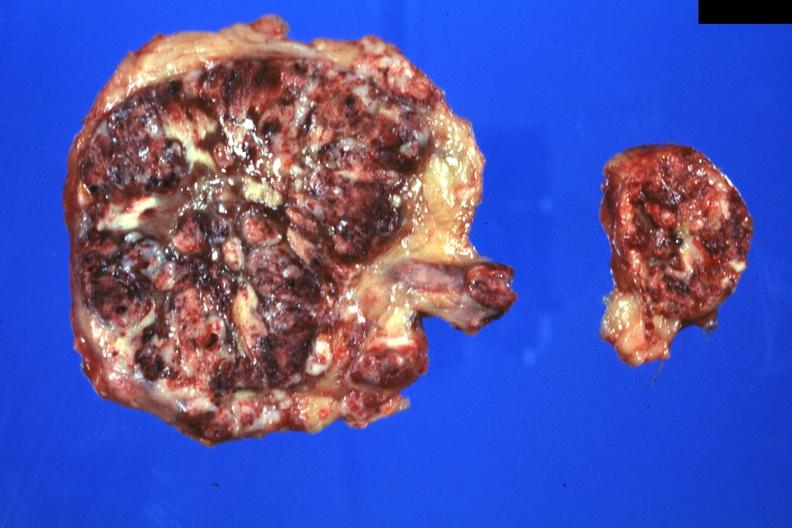what does this image show?
Answer the question using a single word or phrase. Massive replacement can not see any adrenal tissue 